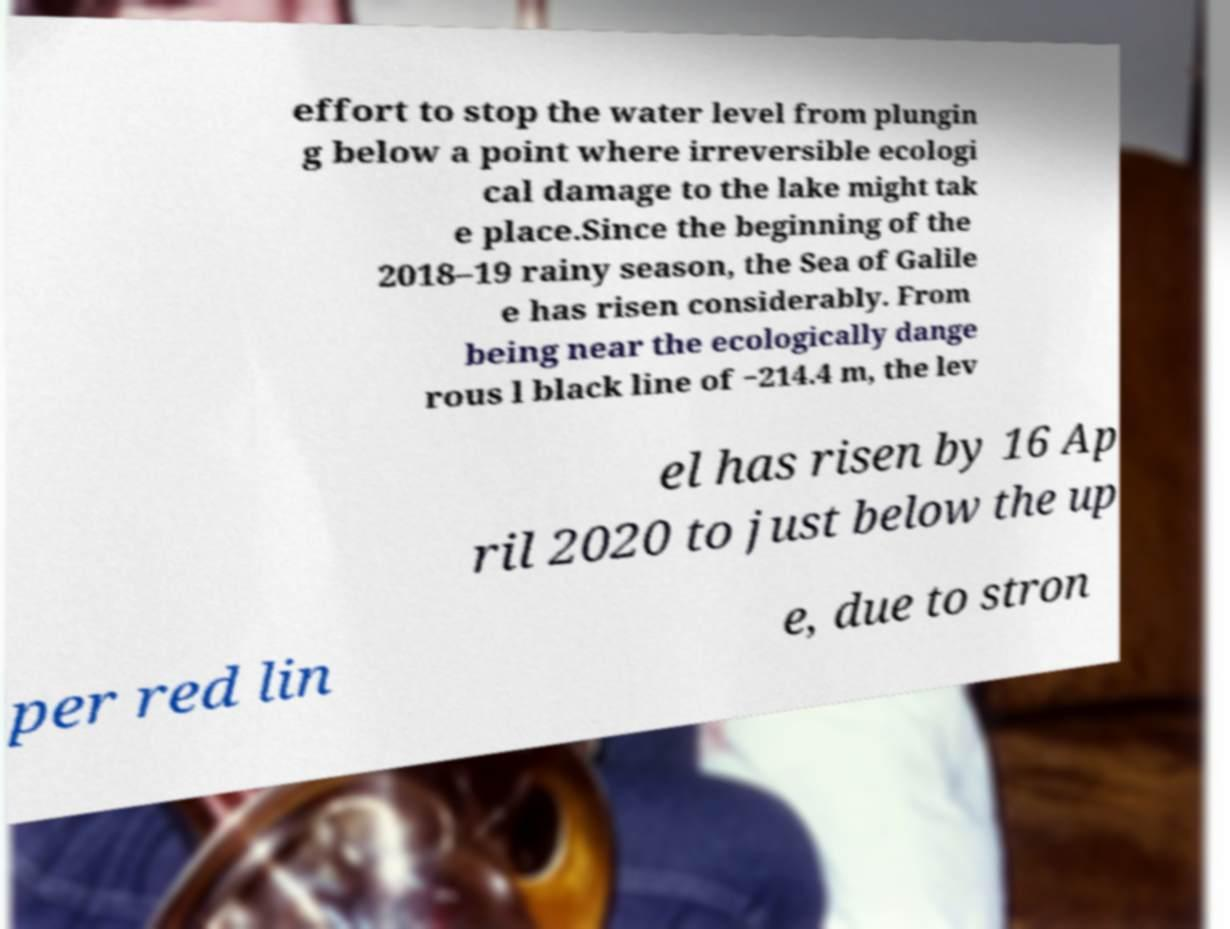Can you accurately transcribe the text from the provided image for me? effort to stop the water level from plungin g below a point where irreversible ecologi cal damage to the lake might tak e place.Since the beginning of the 2018–19 rainy season, the Sea of Galile e has risen considerably. From being near the ecologically dange rous l black line of −214.4 m, the lev el has risen by 16 Ap ril 2020 to just below the up per red lin e, due to stron 